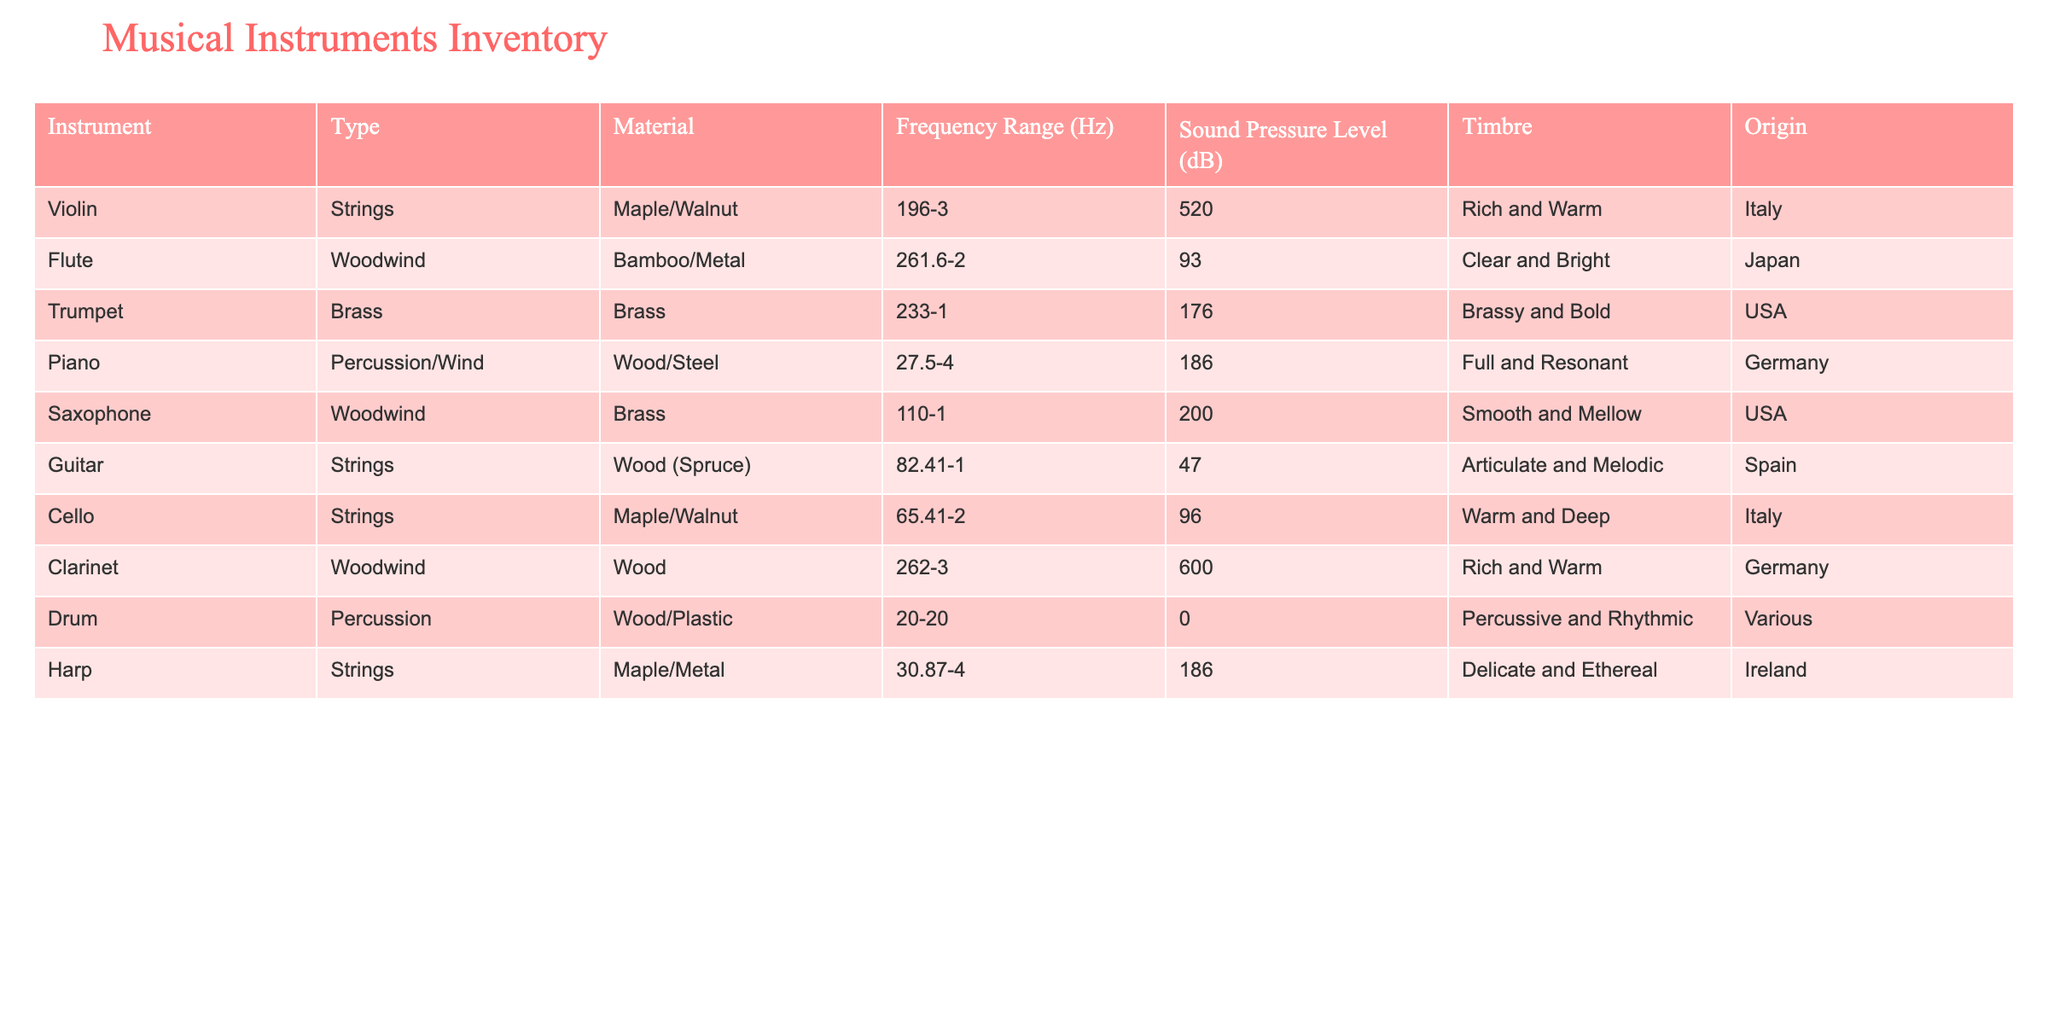What is the sound pressure level of the Cello? The table shows that the sound pressure level for the Cello is 96 dB. This can be directly read from the corresponding row for Cello in the "Sound Pressure Level (dB)" column.
Answer: 96 dB Which instrument has the highest frequency range? The Piano has the highest frequency range listed in the table, which is from 27.5 to 4,186 Hz. This can be confirmed by comparing the frequency ranges of all instruments in the "Frequency Range (Hz)" column.
Answer: Piano Is the material of the Flute wood or metal? The Flute is made of Bamboo and Metal. This information can be found directly in the "Material" column corresponding to the Flute.
Answer: No What instruments originate from Italy? There are two instruments that originate from Italy: the Violin and Cello. This is concluded by filtering the "Origin" column for entries labeled "Italy" and observing which instruments correspond to those entries.
Answer: Violin, Cello Which type of instrument has the lowest frequency range? The Drum has the lowest frequency range, spanning from 20 to 20,000 Hz. This is determined by comparing the "Frequency Range (Hz)" values across all instruments.
Answer: Drum How many string instruments are listed in the table? The table lists a total of four string instruments: Violin, Guitar, Cello, and Harp. I counted these instruments in the "Type" column that specifically mention "Strings".
Answer: 4 What is the average sound pressure level of woodwind instruments? The woodwind instruments listed are Flute, Saxophone, and Clarinet, which have sound pressure levels of 87, 85, and 96 dB respectively. The average sound pressure level can be calculated by adding them (87 + 85 + 96 = 268 dB) and dividing by the number of instruments (3). Therefore, the average is 268/3 = 89.33 dB.
Answer: 89.33 dB Is there an instrument made of both wood and plastic? Yes, the Drum is made of Wood and Plastic. This is verified by checking the "Material" column for the Drum entry.
Answer: Yes Which instrument has the sound characterized as smooth and mellow? The Saxophone is characterized as having a smooth and mellow timbre. This can be directly referenced from the "Timbre" column related to the Saxophone within the table.
Answer: Saxophone 